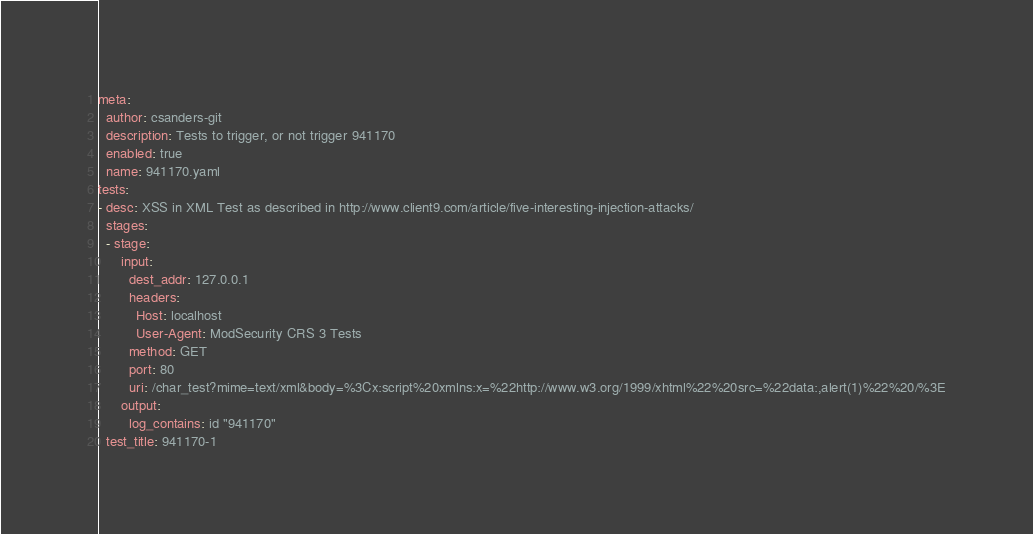<code> <loc_0><loc_0><loc_500><loc_500><_YAML_>meta:
  author: csanders-git
  description: Tests to trigger, or not trigger 941170
  enabled: true
  name: 941170.yaml
tests:
- desc: XSS in XML Test as described in http://www.client9.com/article/five-interesting-injection-attacks/
  stages:
  - stage:
      input:
        dest_addr: 127.0.0.1
        headers:
          Host: localhost
          User-Agent: ModSecurity CRS 3 Tests
        method: GET
        port: 80
        uri: /char_test?mime=text/xml&body=%3Cx:script%20xmlns:x=%22http://www.w3.org/1999/xhtml%22%20src=%22data:,alert(1)%22%20/%3E
      output:
        log_contains: id "941170"
  test_title: 941170-1
</code> 